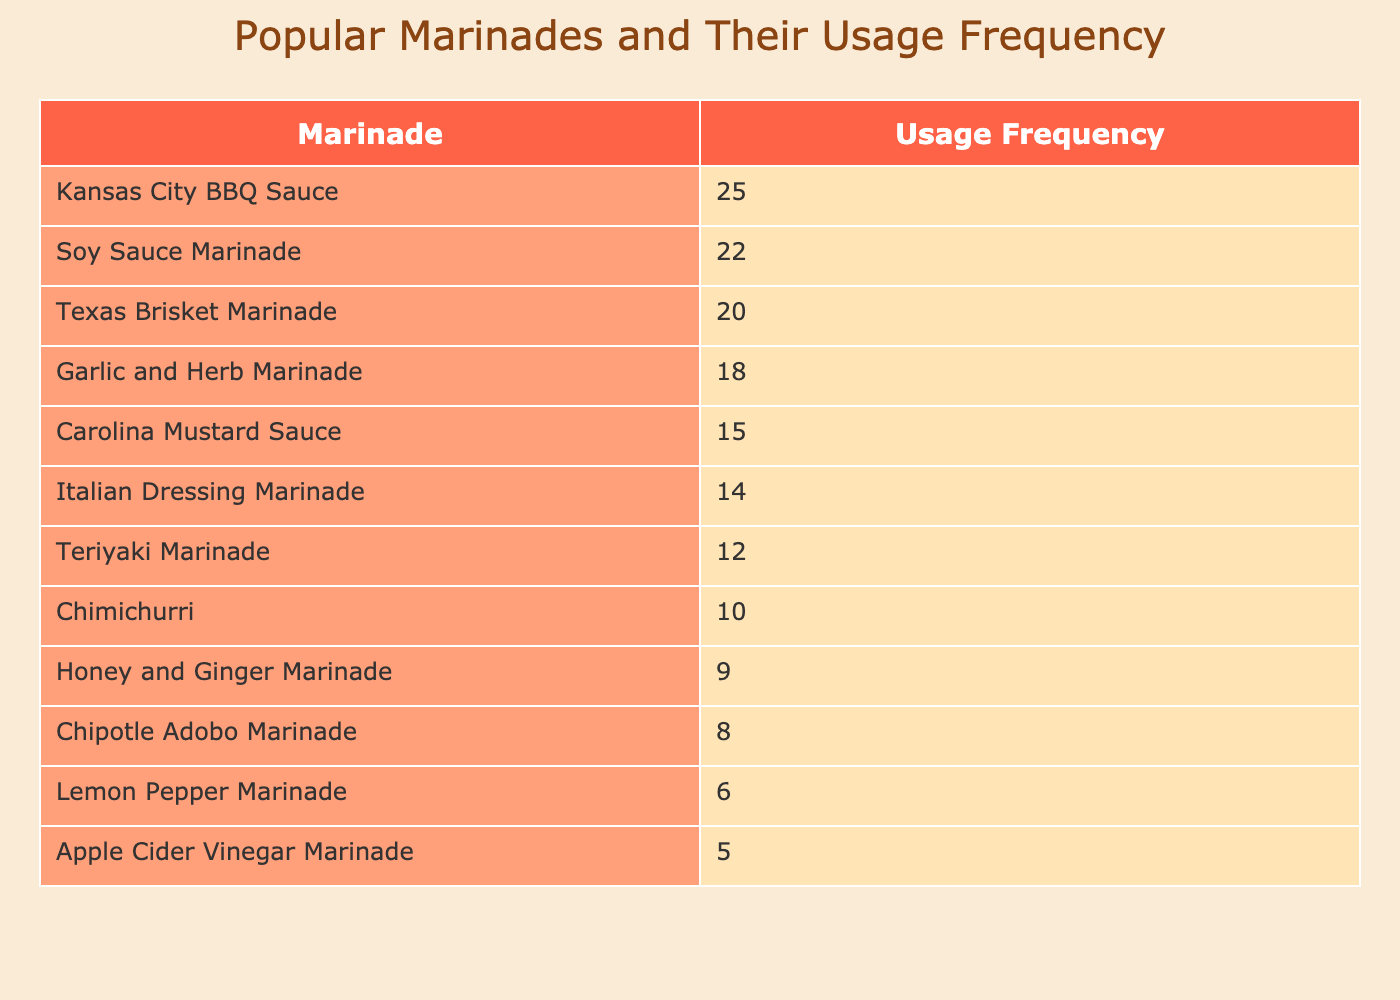What is the usage frequency of Kansas City BBQ Sauce? The table lists Kansas City BBQ Sauce with a usage frequency of 25. It is one of the marinades with the highest usage frequency among those displayed.
Answer: 25 Which marinade has the lowest usage frequency? By reviewing the table, Apple Cider Vinegar Marinade has the lowest usage frequency at 5, making it the least popular choice among those listed.
Answer: 5 What is the total usage frequency of the top three marinades? The top three marinades based on usage frequency are Kansas City BBQ Sauce (25), Soy Sauce Marinade (22), and Texas Brisket Marinade (20). Summing their frequencies gives 25 + 22 + 20 = 67.
Answer: 67 Is Teriyaki Marinade more popular than Garlic and Herb Marinade? The usage frequency for Teriyaki Marinade is 12, while Garlic and Herb Marinade has a frequency of 18. Since 12 is less than 18, Teriyaki Marinade is not more popular.
Answer: No What is the average usage frequency of the marinades presented in the table? To find the average, we first sum the usage frequencies: 25 + 15 + 20 + 10 + 12 + 18 + 14 + 8 + 22 + 6 + 5 + 9 =  229. There are 12 marinades, so the average is 229 / 12 = approximately 19.08.
Answer: 19.08 How many marinades have a usage frequency greater than 15? By examining the table, I count the marinades that exceed a usage frequency of 15: Kansas City BBQ Sauce (25), Texas Brisket Marinade (20), Soy Sauce Marinade (22), Garlic and Herb Marinade (18), and Italian Dressing Marinade (14) counts as four (ignoring the last one as the cutoff is 15). Therefore, there are 6 marinades that are over 15, namely the first five listed plus one (Carolina Mustard Sauce).
Answer: 6 Which marinade has a usage frequency that is exactly double that of the Lemon Pepper Marinade? Lemon Pepper Marinade has a frequency of 6. The only marinade that has a usage frequency double that number is Kansas City BBQ Sauce with a frequency of 25. However, none of the available marinades have exactly 12, which would be double. Therefore, none exist.
Answer: No What is the difference in usage frequency between Chipotle Adobo Marinade and Carolina Mustard Sauce? Chipotle Adobo Marinade has a usage frequency of 8, and Carolina Mustard Sauce has a frequency of 15. The difference is calculated by subtracting the smaller from the larger, so 15 - 8 = 7.
Answer: 7 